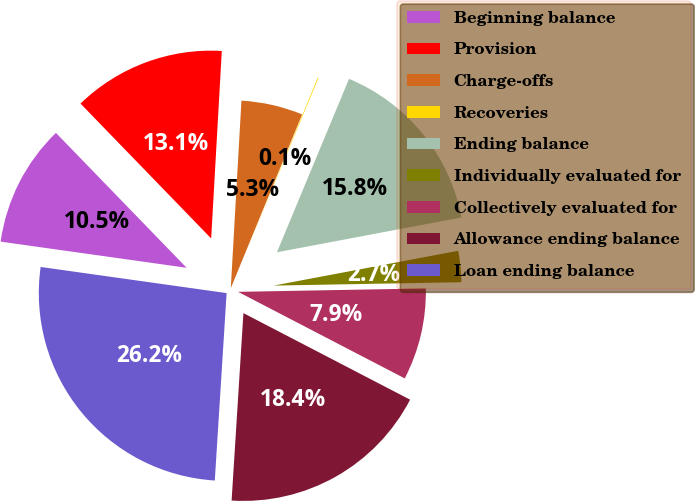Convert chart. <chart><loc_0><loc_0><loc_500><loc_500><pie_chart><fcel>Beginning balance<fcel>Provision<fcel>Charge-offs<fcel>Recoveries<fcel>Ending balance<fcel>Individually evaluated for<fcel>Collectively evaluated for<fcel>Allowance ending balance<fcel>Loan ending balance<nl><fcel>10.53%<fcel>13.15%<fcel>5.3%<fcel>0.07%<fcel>15.76%<fcel>2.68%<fcel>7.91%<fcel>18.38%<fcel>26.22%<nl></chart> 